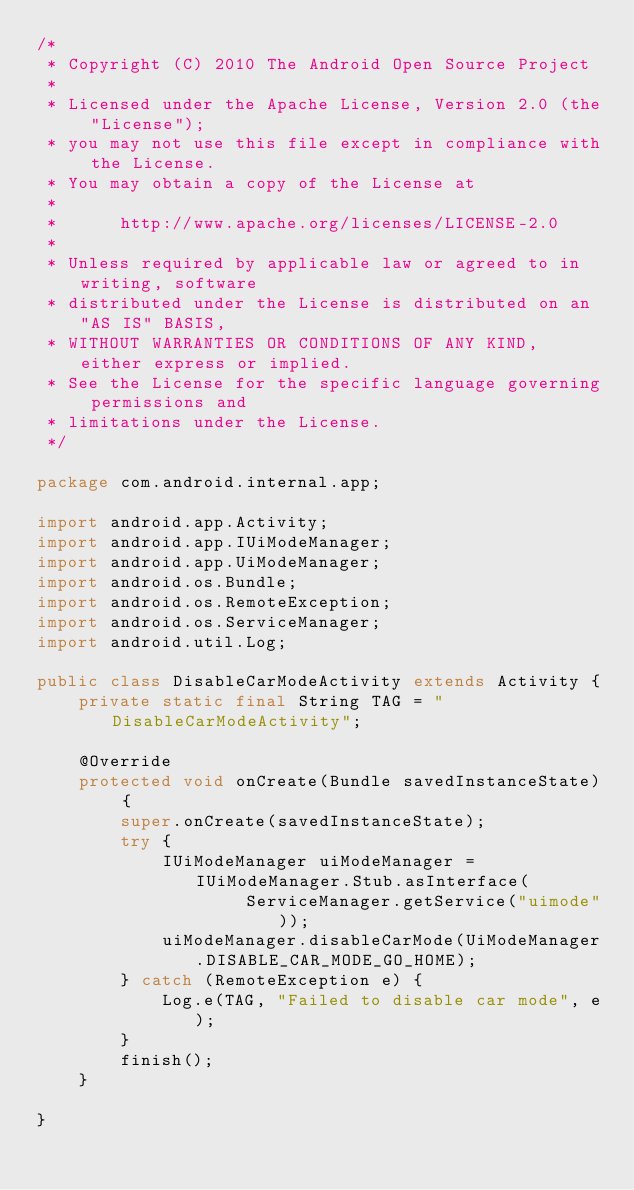Convert code to text. <code><loc_0><loc_0><loc_500><loc_500><_Java_>/*
 * Copyright (C) 2010 The Android Open Source Project
 *
 * Licensed under the Apache License, Version 2.0 (the "License");
 * you may not use this file except in compliance with the License.
 * You may obtain a copy of the License at
 *
 *      http://www.apache.org/licenses/LICENSE-2.0
 *
 * Unless required by applicable law or agreed to in writing, software
 * distributed under the License is distributed on an "AS IS" BASIS,
 * WITHOUT WARRANTIES OR CONDITIONS OF ANY KIND, either express or implied.
 * See the License for the specific language governing permissions and
 * limitations under the License.
 */

package com.android.internal.app;

import android.app.Activity;
import android.app.IUiModeManager;
import android.app.UiModeManager;
import android.os.Bundle;
import android.os.RemoteException;
import android.os.ServiceManager;
import android.util.Log;

public class DisableCarModeActivity extends Activity {
    private static final String TAG = "DisableCarModeActivity";

    @Override
    protected void onCreate(Bundle savedInstanceState) {
        super.onCreate(savedInstanceState);
        try {
            IUiModeManager uiModeManager = IUiModeManager.Stub.asInterface(
                    ServiceManager.getService("uimode"));
            uiModeManager.disableCarMode(UiModeManager.DISABLE_CAR_MODE_GO_HOME);
        } catch (RemoteException e) {
            Log.e(TAG, "Failed to disable car mode", e);
        }
        finish();
    }

}
</code> 